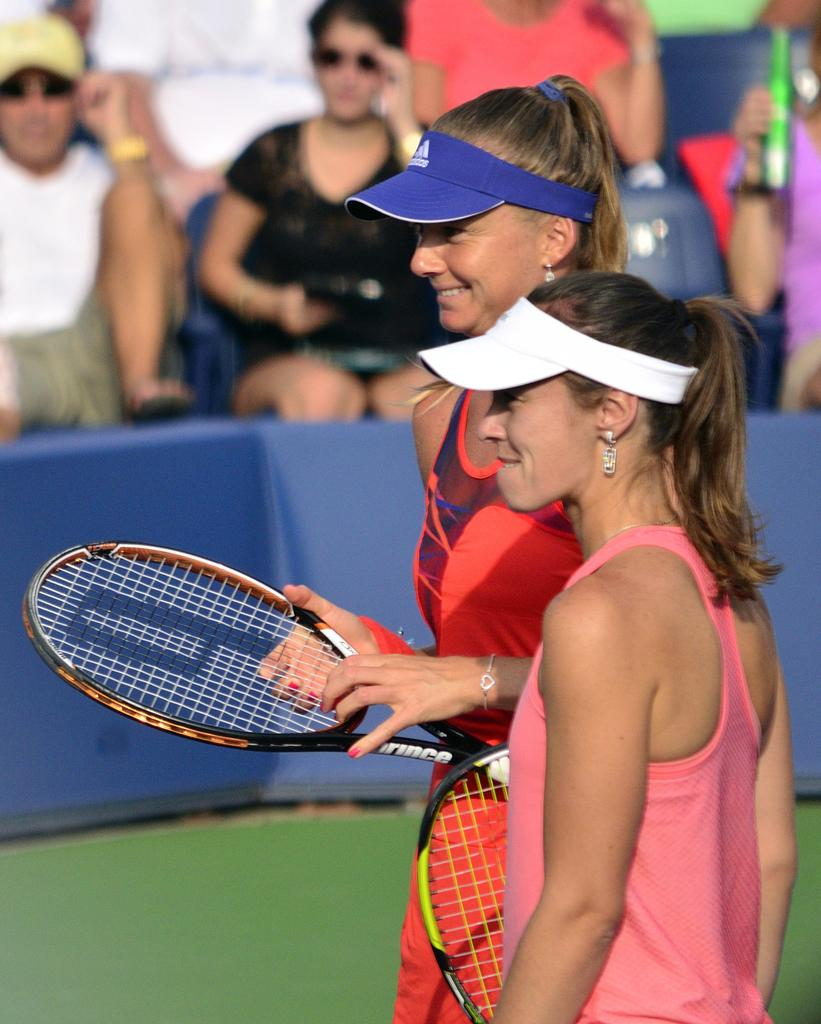Who is present in the image? There are women in the image. What are the women doing in the image? The women are standing in the image. What objects are the women holding in their hands? The women are holding rackets in their hands. What type of juice is being served in the image? There is no juice present in the image. What is the price of the rackets the women are holding? The image does not provide information about the price of the rackets. 